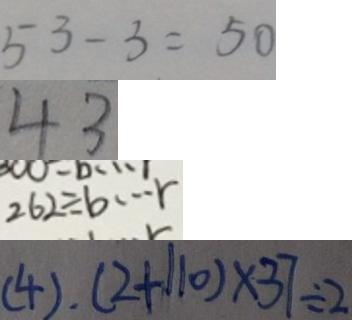Convert formula to latex. <formula><loc_0><loc_0><loc_500><loc_500>5 3 - 3 = 5 0 
 4 3 
 2 6 2 \div b \cdots r 
 ( 4 ) . ( 2 + 1 1 0 ) \times 3 7 \div 2</formula> 